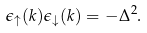Convert formula to latex. <formula><loc_0><loc_0><loc_500><loc_500>\epsilon _ { \uparrow } ( k ) \epsilon _ { \downarrow } ( k ) = - \Delta ^ { 2 } .</formula> 